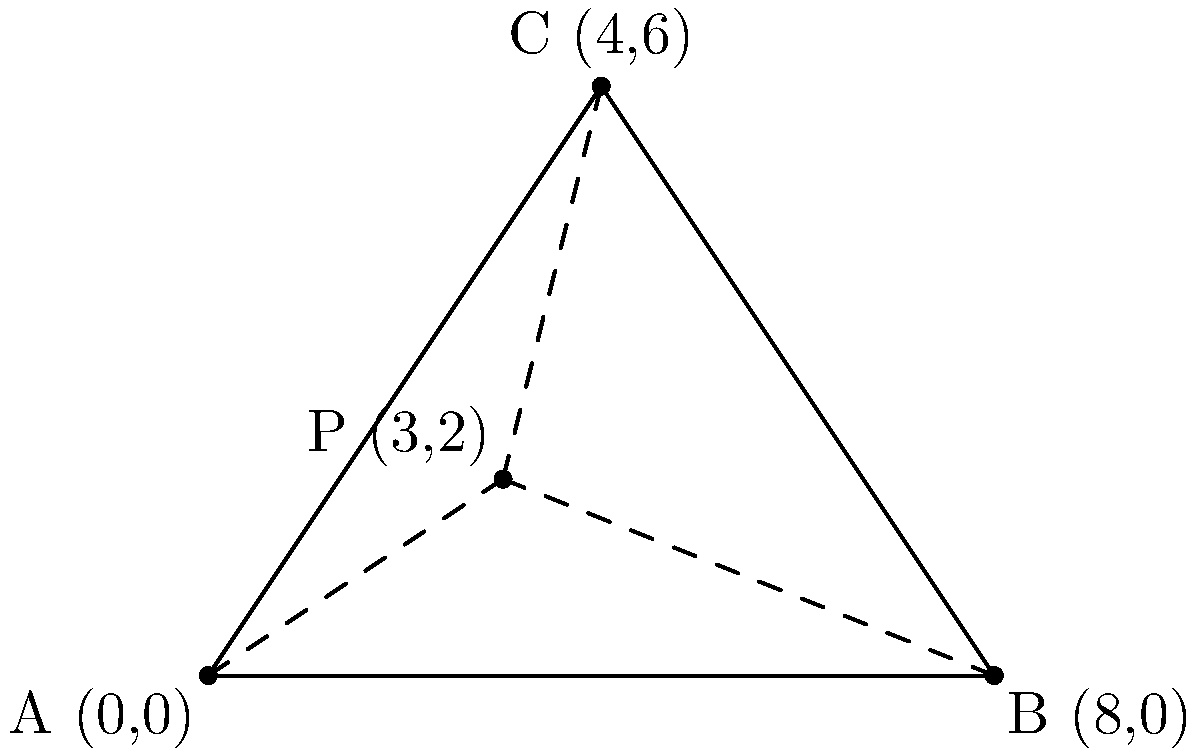An anonymous call has been traced to a location within a triangular area formed by three cell towers. The coordinates of the towers are A(0,0), B(8,0), and C(4,6). Using the triangulation method, you've determined that the call originated from a point P with coordinates (3,2). Calculate the sum of the distances from point P to each of the three cell towers. Round your answer to the nearest tenth. To solve this problem, we need to calculate the distance from point P to each of the three cell towers and then sum these distances. We'll use the distance formula between two points: $d = \sqrt{(x_2-x_1)^2 + (y_2-y_1)^2}$

1. Distance from P to A:
   $PA = \sqrt{(3-0)^2 + (2-0)^2} = \sqrt{9 + 4} = \sqrt{13} \approx 3.6$

2. Distance from P to B:
   $PB = \sqrt{(3-8)^2 + (2-0)^2} = \sqrt{25 + 4} = \sqrt{29} \approx 5.4$

3. Distance from P to C:
   $PC = \sqrt{(3-4)^2 + (2-6)^2} = \sqrt{1 + 16} = \sqrt{17} \approx 4.1$

4. Sum of the distances:
   $PA + PB + PC \approx 3.6 + 5.4 + 4.1 = 13.1$

Rounding to the nearest tenth, our final answer is 13.1.
Answer: 13.1 